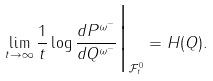Convert formula to latex. <formula><loc_0><loc_0><loc_500><loc_500>\lim _ { t \rightarrow \infty } \frac { 1 } { t } \log \frac { d P ^ { \omega ^ { - } } } { d Q ^ { \omega ^ { - } } } \Big | _ { \mathcal { F } ^ { 0 } _ { t } } = H ( Q ) .</formula> 